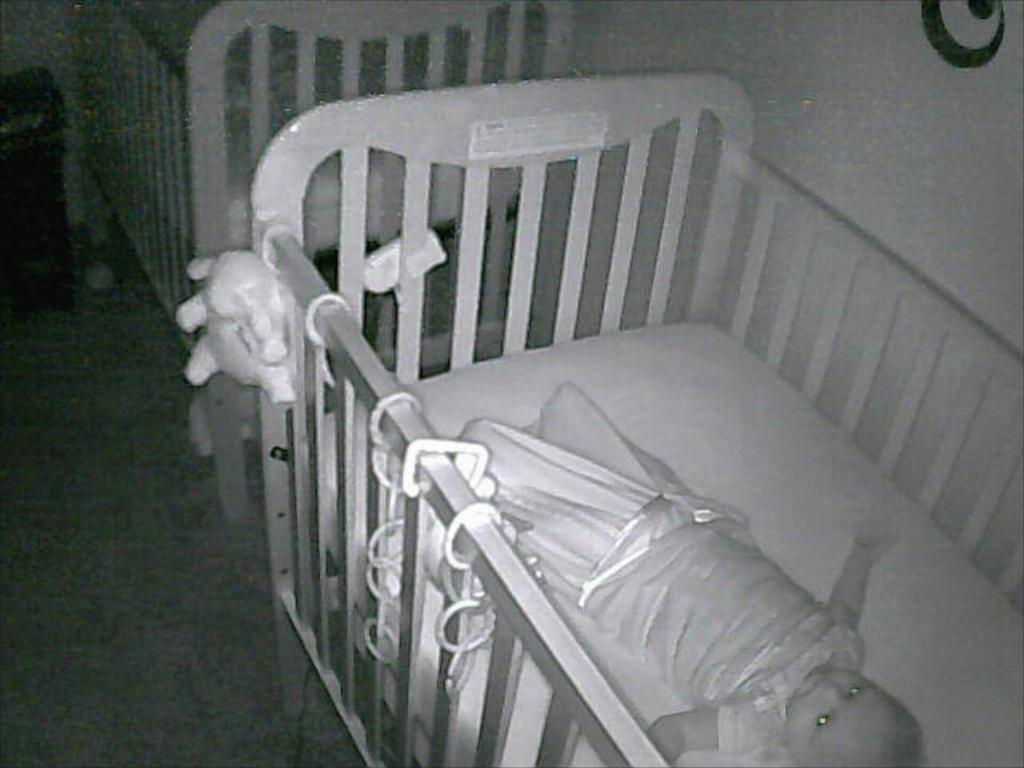How many baby beds are visible in the image? There are two baby beds on the floor in the image. What is the condition of one of the babies in the image? A baby is lying on one of the beds in the image. What can be seen in the background of the room? There is a wall and a table in the background of the image. In which type of setting is the image taken? The image is taken in a room. What type of holiday is being celebrated in the wilderness in the image? There is no wilderness or holiday present in the image; it is taken in a room with baby beds and a baby. 